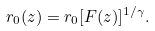Convert formula to latex. <formula><loc_0><loc_0><loc_500><loc_500>r _ { 0 } ( z ) = r _ { 0 } [ F ( z ) ] ^ { 1 / \gamma } .</formula> 